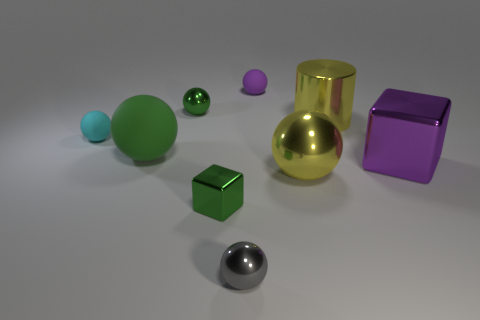Does the big cylinder have the same color as the big metallic ball?
Give a very brief answer. Yes. There is a matte object that is the same color as the tiny cube; what size is it?
Your response must be concise. Large. Are there any tiny spheres that have the same material as the big green sphere?
Provide a succinct answer. Yes. What material is the sphere left of the green matte ball?
Make the answer very short. Rubber. What material is the yellow ball?
Your answer should be compact. Metal. Is the big sphere behind the big purple shiny cube made of the same material as the tiny cyan thing?
Your answer should be very brief. Yes. Are there fewer purple things that are on the right side of the gray metallic thing than tiny objects?
Keep it short and to the point. Yes. What is the color of the other rubber thing that is the same size as the purple matte object?
Ensure brevity in your answer.  Cyan. What number of brown metal things are the same shape as the gray shiny thing?
Your answer should be very brief. 0. What color is the matte thing that is to the right of the small metal cube?
Your answer should be compact. Purple. 